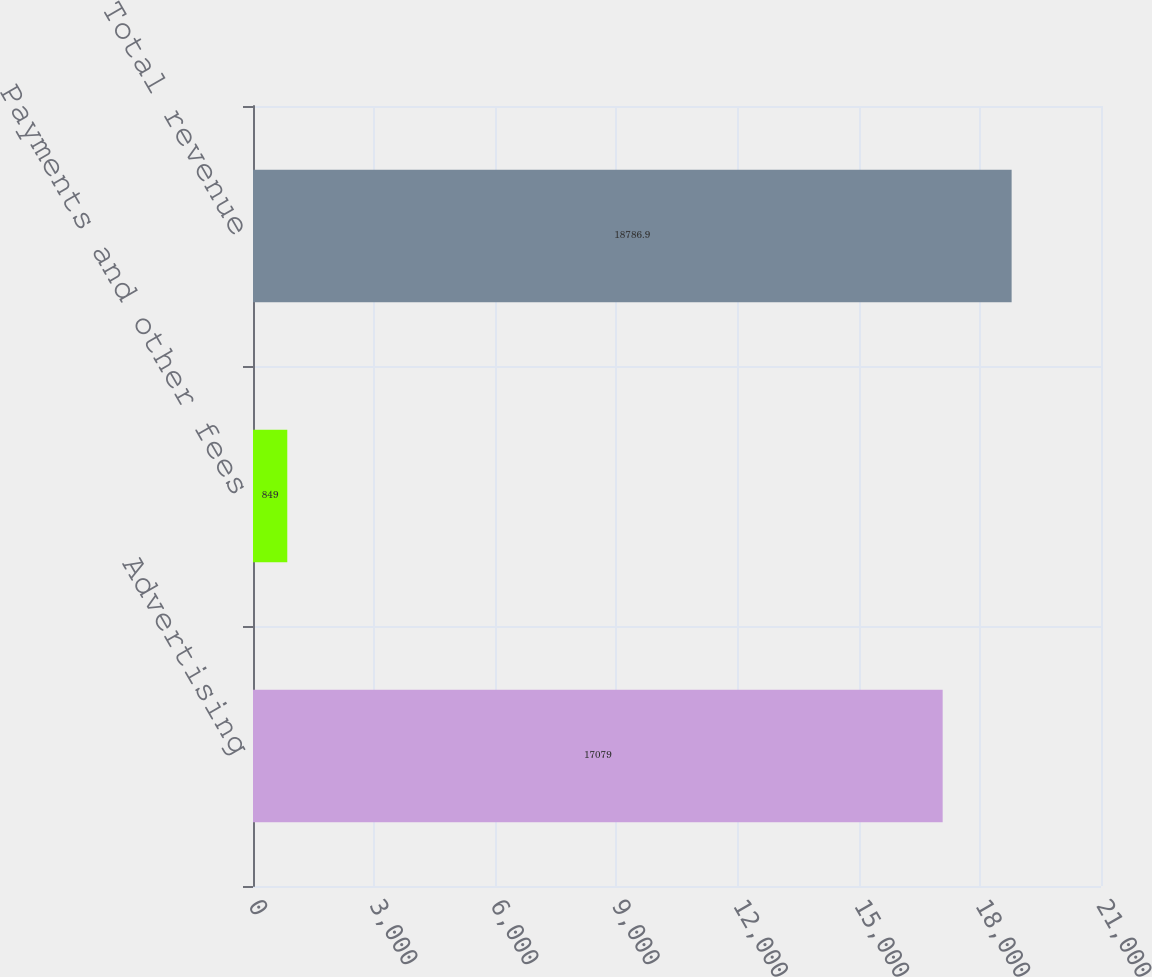<chart> <loc_0><loc_0><loc_500><loc_500><bar_chart><fcel>Advertising<fcel>Payments and other fees<fcel>Total revenue<nl><fcel>17079<fcel>849<fcel>18786.9<nl></chart> 